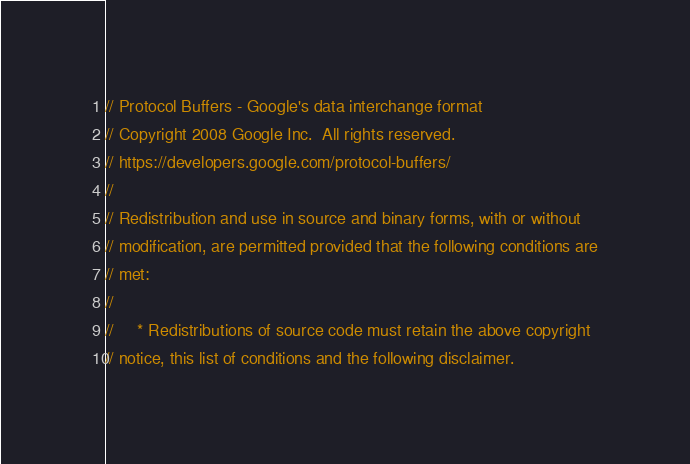<code> <loc_0><loc_0><loc_500><loc_500><_C++_>// Protocol Buffers - Google's data interchange format
// Copyright 2008 Google Inc.  All rights reserved.
// https://developers.google.com/protocol-buffers/
//
// Redistribution and use in source and binary forms, with or without
// modification, are permitted provided that the following conditions are
// met:
//
//     * Redistributions of source code must retain the above copyright
// notice, this list of conditions and the following disclaimer.</code> 